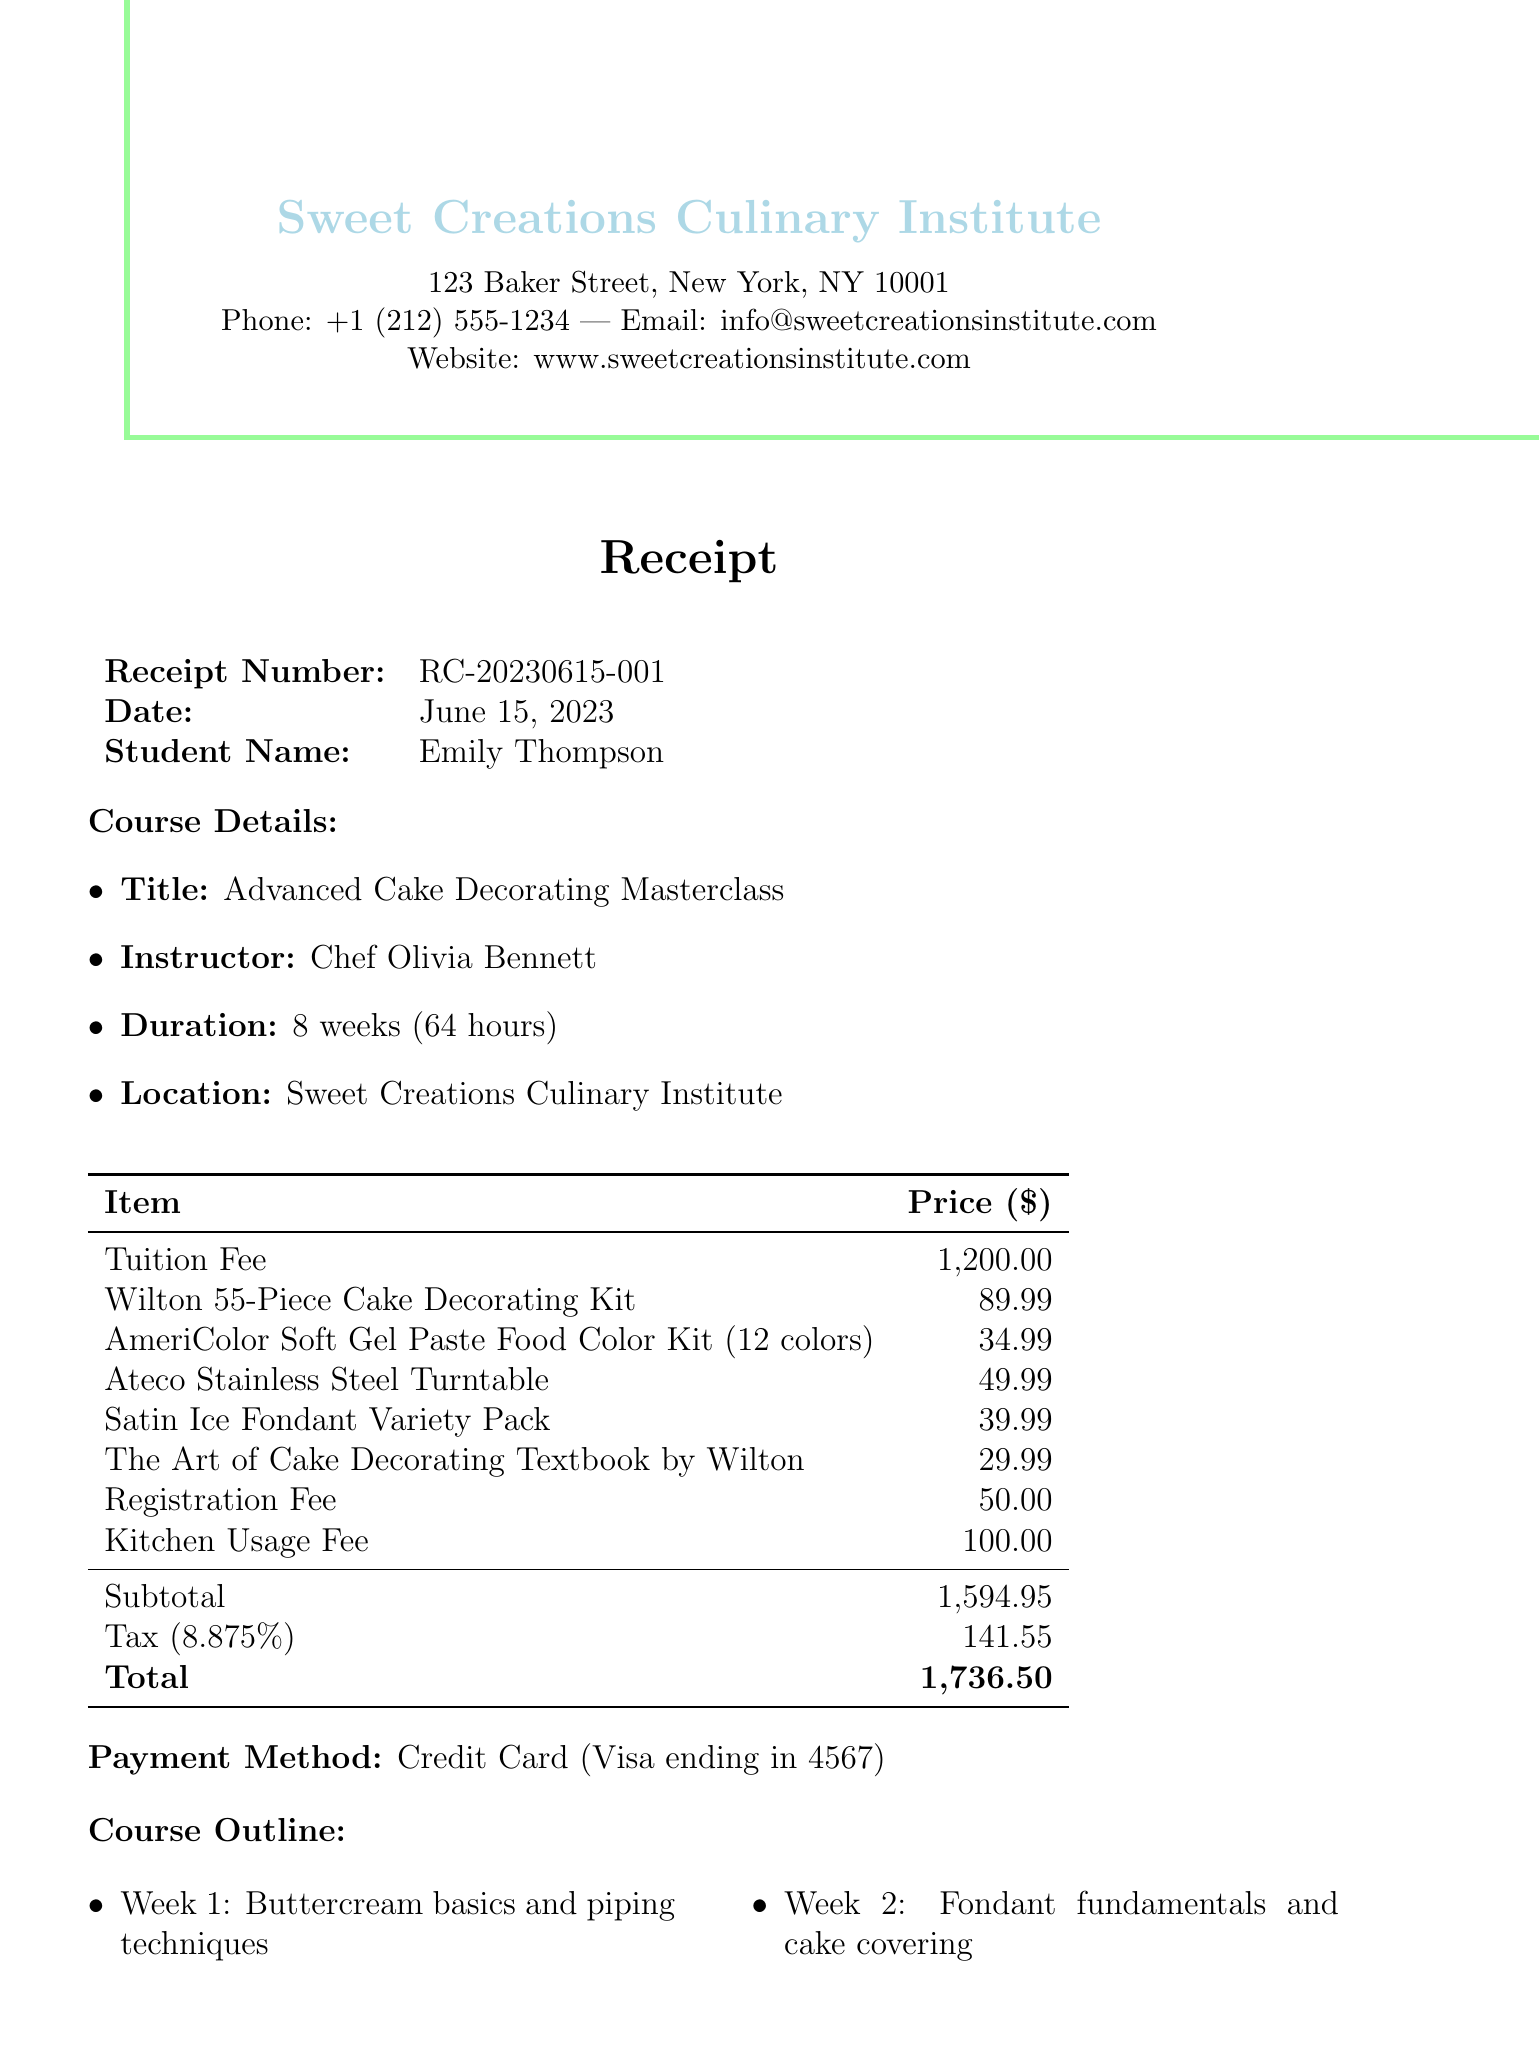What is the receipt number? The receipt number is found under the receipt details section in the document.
Answer: RC-20230615-001 Who is the instructor for the course? The instructor's name is mentioned in the course details section of the document.
Answer: Chef Olivia Bennett What is the tuition fee? The tuition fee is listed in the comprehensive breakdown of class materials and additional fees.
Answer: 1200.00 What is the tax amount? The tax amount is calculated based on the subtotal, and it is clearly mentioned in the fees table.
Answer: 141.55 How many weeks does the course last? The duration of the course is specified directly in the course details section.
Answer: 8 weeks What is the location of the institute? The location is stated in the course details section of the document.
Answer: Sweet Creations Culinary Institute, 123 Baker Street, New York, NY 10001 What is the refund policy for cancellations made 10 days before the course starts? The refund policy for cancellations earlier than 14 days is outlined in the cancellation policy section.
Answer: Full refund available What item is associated with the price of 39.99? The price of 39.99 corresponds to one of the class materials listed.
Answer: Satin Ice Fondant Variety Pack What payment method was used for this transaction? The payment method is mentioned in the payment details section of the document.
Answer: Credit Card (Visa ending in 4567) 